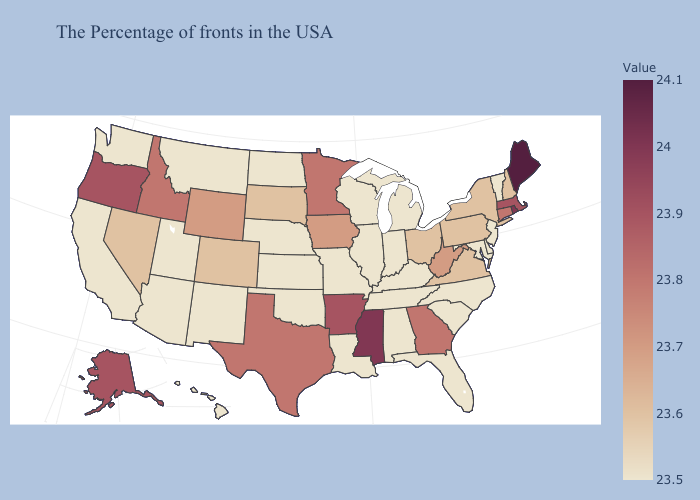Among the states that border Michigan , does Indiana have the highest value?
Be succinct. No. Which states have the highest value in the USA?
Be succinct. Maine. Among the states that border Maryland , does West Virginia have the highest value?
Short answer required. Yes. Does Pennsylvania have a higher value than South Carolina?
Quick response, please. Yes. Among the states that border North Carolina , does Tennessee have the highest value?
Quick response, please. No. 